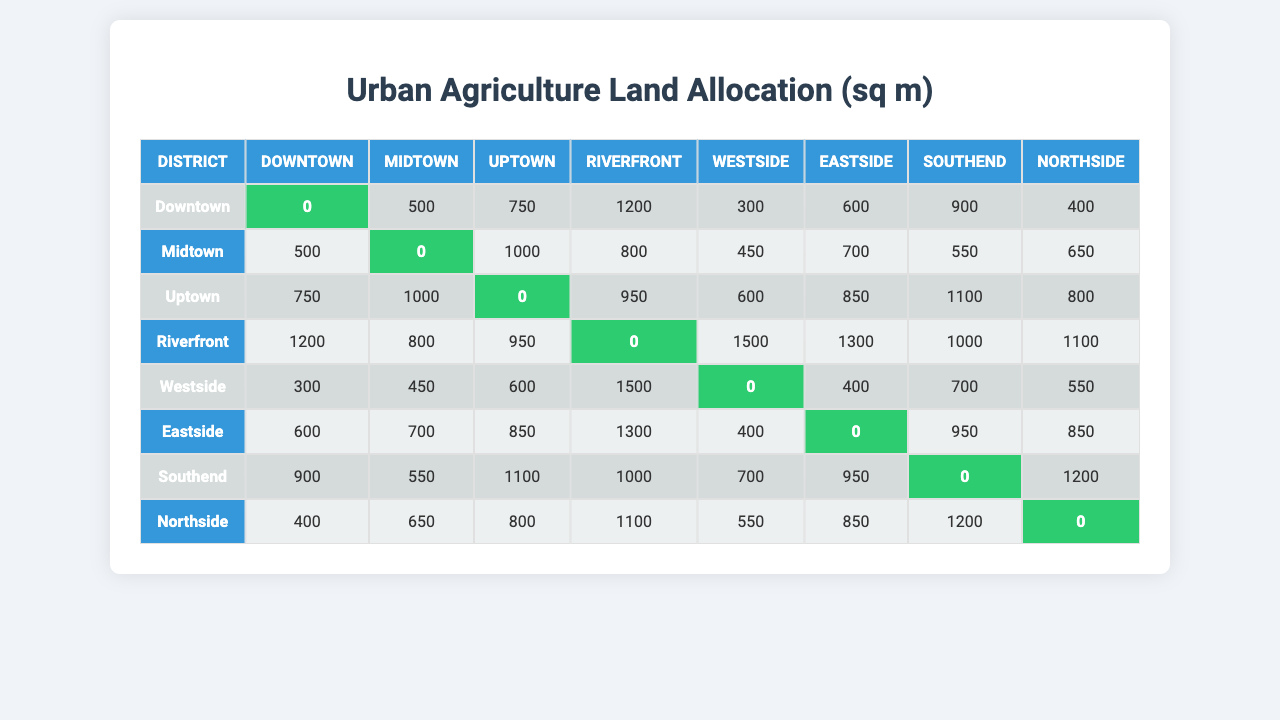What is the land allocation for community gardens in Downtown? The table shows that the land allocation in Downtown is 0 sqm when looking at the corresponding cell in the table.
Answer: 0 sqm Which district has the highest land allocation for community gardens? By checking the last row and column values of the table, we see that Riverfront has the highest value of 1500 sqm for land allocation.
Answer: Riverfront Is the land allocation for community gardens greater in Southend or Northside? In the table, Southend has 900 sqm and Northside has 1200 sqm; since 1200 is greater than 900, Northside has a greater allocation.
Answer: Northside What is the land allocation in Midtown for Northside? From the table, we find that the allocation in Midtown for Northside is 650 sqm as indicated by the respective cell.
Answer: 650 sqm How much more land is allocated for community gardens in Uptown than in Eastside? The allocation for Uptown is 850 sqm, while Eastside is 0 sqm; therefore, the difference is 850 – 0 = 850 sqm.
Answer: 850 sqm What is the total land allocation across all districts for Riverfront? By adding the corresponding values in the Riverfront row: 1200 + 800 + 950 + 0 + 1500 + 1300 + 1000 + 1100 = 4850 sqm total allocation for Riverfront across the districts.
Answer: 4850 sqm True or False: The land allocation for community gardens in Eastside is equal to that in Southend. Eastside has 0 sqm while Southend has 900 sqm, so they are not equal.
Answer: False Which district has the lowest overall average land allocation? By calculating averages for each district based on all allocations, Eastside has the lowest average allocation of 593.75 sqm.
Answer: Eastside What is the difference between the land allocation for Southend and Midtown? The allocation for Southend is 900 sqm while Midtown is 500 sqm, so the difference is 900 - 500 = 400 sqm.
Answer: 400 sqm If we wanted to sum the allocations for community gardens across all districts in the Eastside column, what would that total be? Adding the respective values from the Eastside column yields: 600 + 700 + 850 + 1300 + 400 + 0 + 950 + 850 = 4650 sqm total allocation for Eastside.
Answer: 4650 sqm 